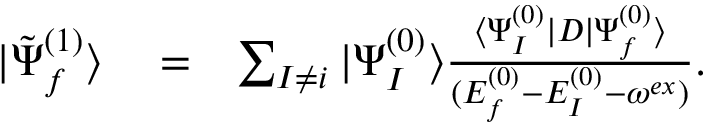<formula> <loc_0><loc_0><loc_500><loc_500>\begin{array} { r l r } { | \tilde { \Psi } _ { f } ^ { ( 1 ) } \rangle } & = } & { \sum _ { I \ne i } | \Psi _ { I } ^ { ( 0 ) } \rangle \frac { \langle \Psi _ { I } ^ { ( 0 ) } | D | \Psi _ { f } ^ { ( 0 ) } \rangle } { ( E _ { f } ^ { ( 0 ) } - E _ { I } ^ { ( 0 ) } - \omega ^ { e x } ) } . } \end{array}</formula> 